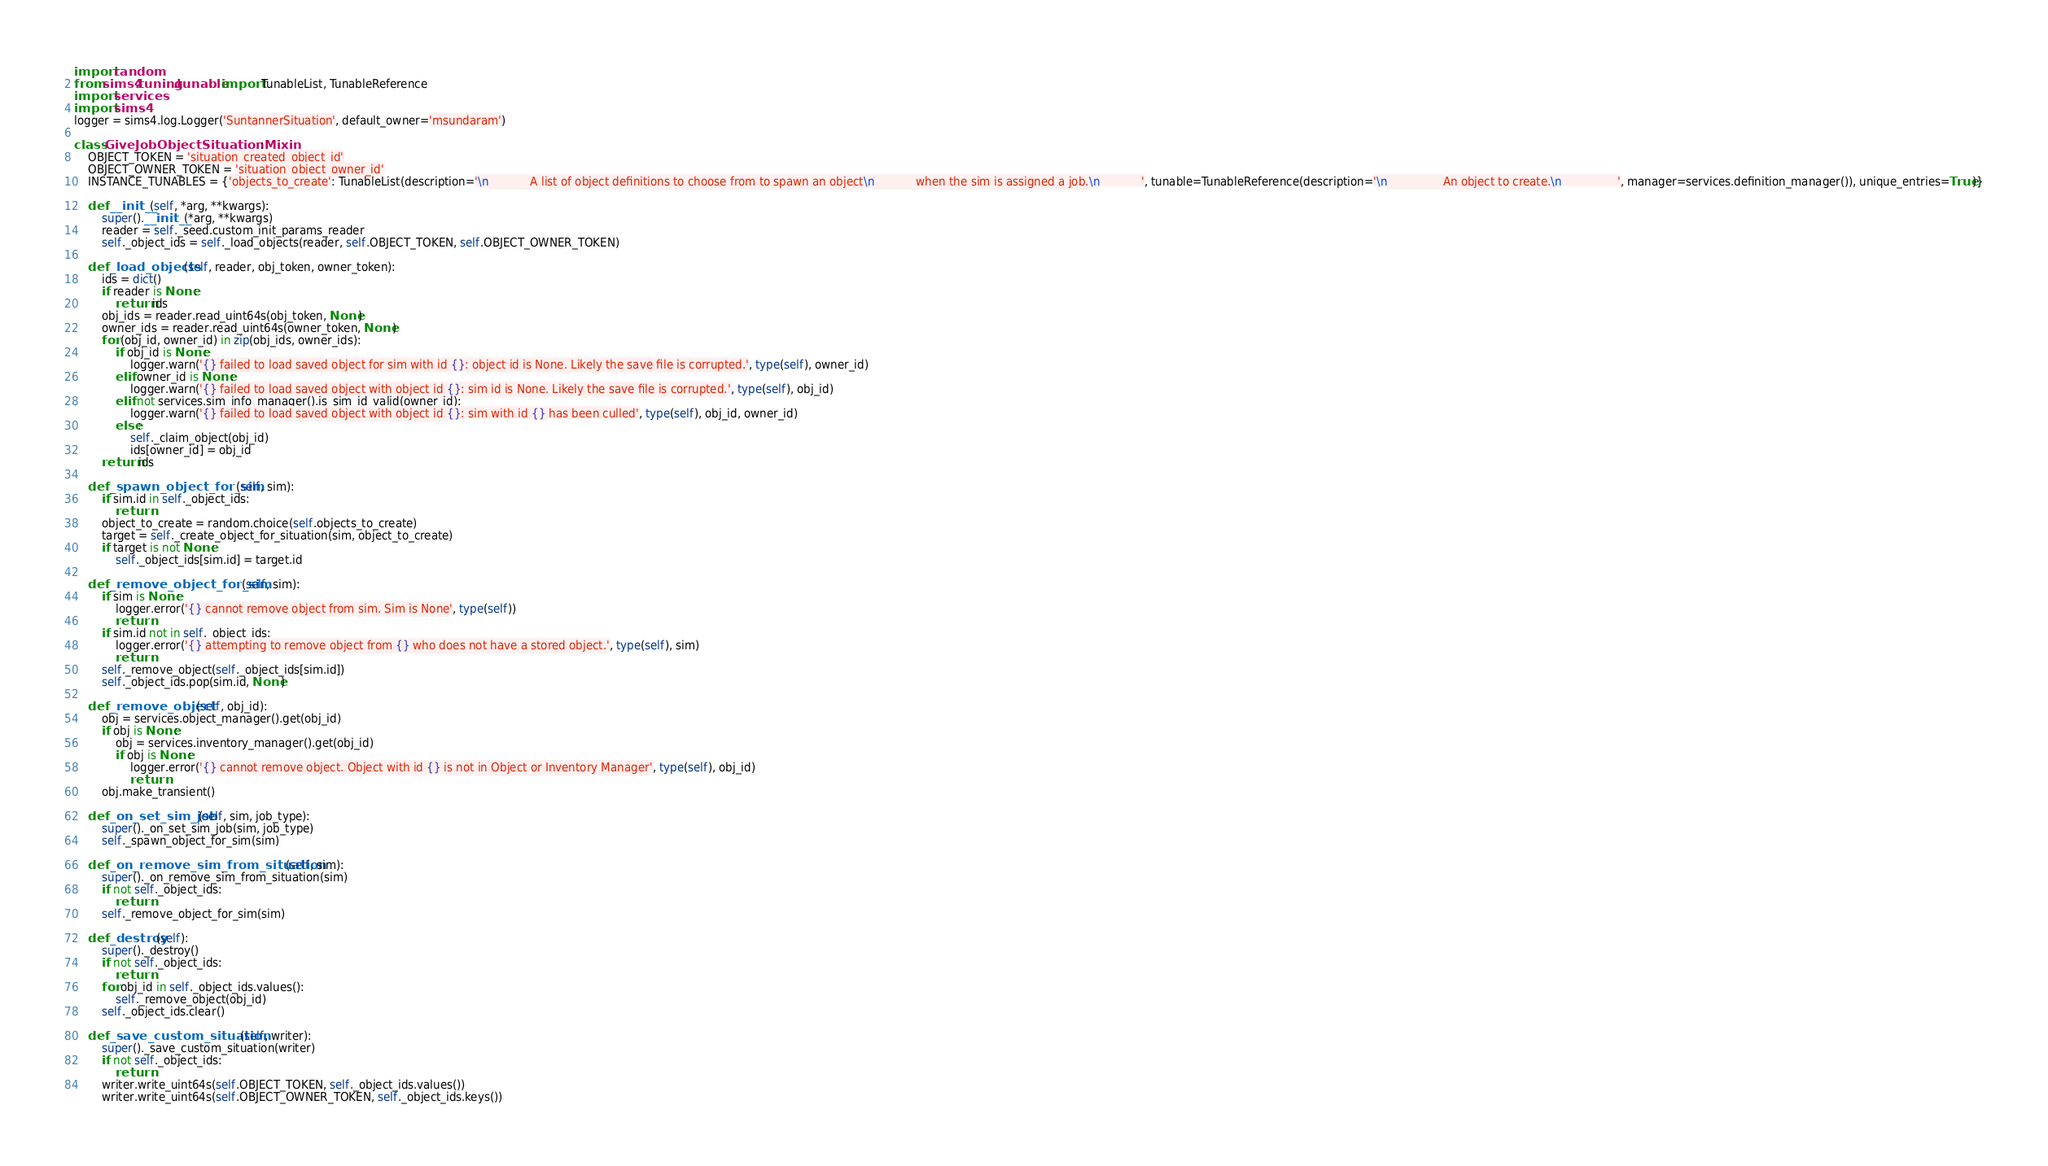Convert code to text. <code><loc_0><loc_0><loc_500><loc_500><_Python_>import random
from sims4.tuning.tunable import TunableList, TunableReference
import services
import sims4
logger = sims4.log.Logger('SuntannerSituation', default_owner='msundaram')

class GiveJobObjectSituationMixin:
    OBJECT_TOKEN = 'situation_created_object_id'
    OBJECT_OWNER_TOKEN = 'situation_object_owner_id'
    INSTANCE_TUNABLES = {'objects_to_create': TunableList(description='\n            A list of object definitions to choose from to spawn an object\n            when the sim is assigned a job.\n            ', tunable=TunableReference(description='\n                An object to create.\n                ', manager=services.definition_manager()), unique_entries=True)}

    def __init__(self, *arg, **kwargs):
        super().__init__(*arg, **kwargs)
        reader = self._seed.custom_init_params_reader
        self._object_ids = self._load_objects(reader, self.OBJECT_TOKEN, self.OBJECT_OWNER_TOKEN)

    def _load_objects(self, reader, obj_token, owner_token):
        ids = dict()
        if reader is None:
            return ids
        obj_ids = reader.read_uint64s(obj_token, None)
        owner_ids = reader.read_uint64s(owner_token, None)
        for (obj_id, owner_id) in zip(obj_ids, owner_ids):
            if obj_id is None:
                logger.warn('{} failed to load saved object for sim with id {}: object id is None. Likely the save file is corrupted.', type(self), owner_id)
            elif owner_id is None:
                logger.warn('{} failed to load saved object with object id {}: sim id is None. Likely the save file is corrupted.', type(self), obj_id)
            elif not services.sim_info_manager().is_sim_id_valid(owner_id):
                logger.warn('{} failed to load saved object with object id {}: sim with id {} has been culled', type(self), obj_id, owner_id)
            else:
                self._claim_object(obj_id)
                ids[owner_id] = obj_id
        return ids

    def _spawn_object_for_sim(self, sim):
        if sim.id in self._object_ids:
            return
        object_to_create = random.choice(self.objects_to_create)
        target = self._create_object_for_situation(sim, object_to_create)
        if target is not None:
            self._object_ids[sim.id] = target.id

    def _remove_object_for_sim(self, sim):
        if sim is None:
            logger.error('{} cannot remove object from sim. Sim is None', type(self))
            return
        if sim.id not in self._object_ids:
            logger.error('{} attempting to remove object from {} who does not have a stored object.', type(self), sim)
            return
        self._remove_object(self._object_ids[sim.id])
        self._object_ids.pop(sim.id, None)

    def _remove_object(self, obj_id):
        obj = services.object_manager().get(obj_id)
        if obj is None:
            obj = services.inventory_manager().get(obj_id)
            if obj is None:
                logger.error('{} cannot remove object. Object with id {} is not in Object or Inventory Manager', type(self), obj_id)
                return
        obj.make_transient()

    def _on_set_sim_job(self, sim, job_type):
        super()._on_set_sim_job(sim, job_type)
        self._spawn_object_for_sim(sim)

    def _on_remove_sim_from_situation(self, sim):
        super()._on_remove_sim_from_situation(sim)
        if not self._object_ids:
            return
        self._remove_object_for_sim(sim)

    def _destroy(self):
        super()._destroy()
        if not self._object_ids:
            return
        for obj_id in self._object_ids.values():
            self._remove_object(obj_id)
        self._object_ids.clear()

    def _save_custom_situation(self, writer):
        super()._save_custom_situation(writer)
        if not self._object_ids:
            return
        writer.write_uint64s(self.OBJECT_TOKEN, self._object_ids.values())
        writer.write_uint64s(self.OBJECT_OWNER_TOKEN, self._object_ids.keys())
</code> 